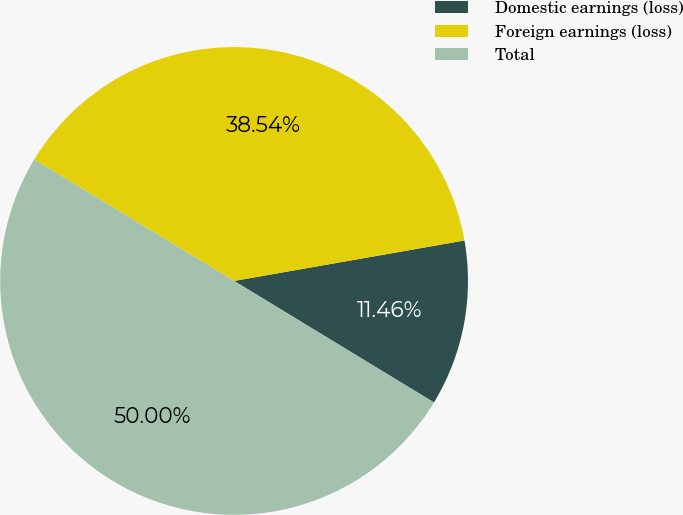<chart> <loc_0><loc_0><loc_500><loc_500><pie_chart><fcel>Domestic earnings (loss)<fcel>Foreign earnings (loss)<fcel>Total<nl><fcel>11.46%<fcel>38.54%<fcel>50.0%<nl></chart> 